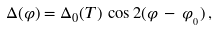<formula> <loc_0><loc_0><loc_500><loc_500>\Delta ( \varphi ) = \Delta _ { 0 } ( T ) \, \cos 2 ( \varphi \, - \, \varphi _ { _ { 0 } } ) \, ,</formula> 